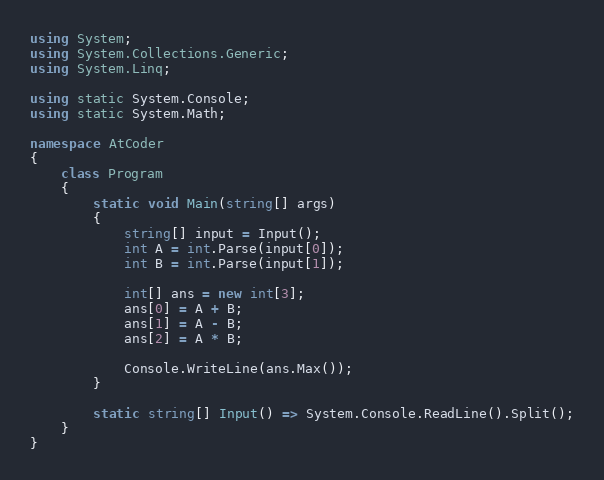<code> <loc_0><loc_0><loc_500><loc_500><_C#_>using System;
using System.Collections.Generic;
using System.Linq;

using static System.Console;
using static System.Math;

namespace AtCoder
{
    class Program
    {
        static void Main(string[] args)
        {
            string[] input = Input();
            int A = int.Parse(input[0]);
            int B = int.Parse(input[1]);

            int[] ans = new int[3];
            ans[0] = A + B;
            ans[1] = A - B;
            ans[2] = A * B;

            Console.WriteLine(ans.Max());
        }

        static string[] Input() => System.Console.ReadLine().Split();
    }
}
</code> 